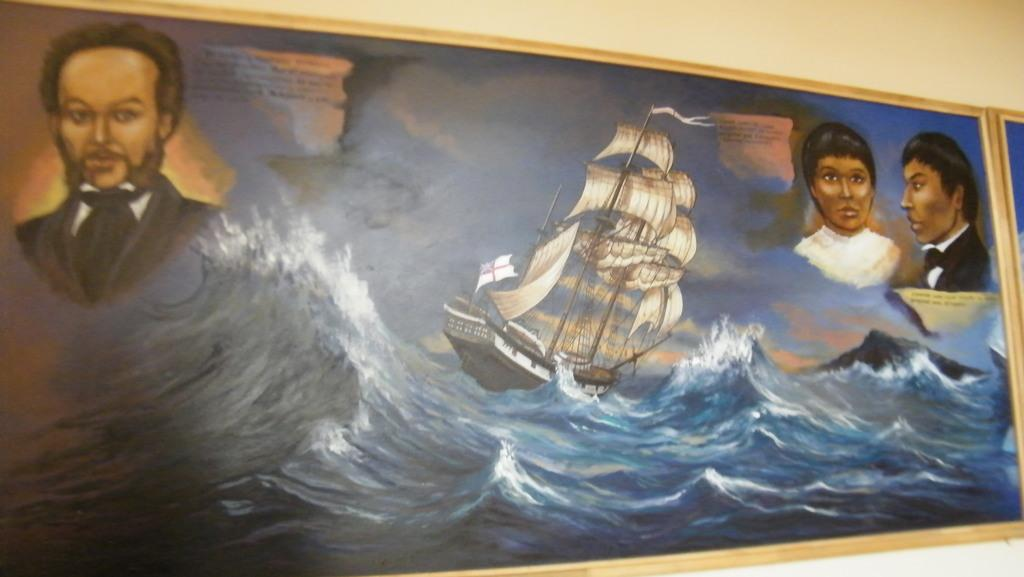What is the main subject of the painting? There is a ship in the painting. Are there any other elements in the painting besides the ship? Yes, there are people and water in the painting. Where is the painting located? The painting is displayed on a wall. How many rabbits can be seen playing with a pan in the painting? There are no rabbits or pans present in the painting; it features a ship, people, and water. 